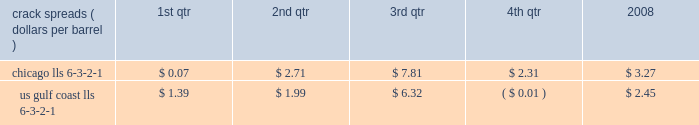Our refining and wholesale marketing gross margin is the difference between the prices of refined products sold and the costs of crude oil and other charge and blendstocks refined , including the costs to transport these inputs to our refineries , the costs of purchased products and manufacturing expenses , including depreciation .
The crack spread is a measure of the difference between market prices for refined products and crude oil , commonly used by the industry as an indicator of the impact of price on the refining margin .
Crack spreads can fluctuate significantly , particularly when prices of refined products do not move in the same relationship as the cost of crude oil .
As a performance benchmark and a comparison with other industry participants , we calculate midwest ( chicago ) and u.s .
Gulf coast crack spreads that we feel most closely track our operations and slate of products .
Posted light louisiana sweet ( 201clls 201d ) prices and a 6-3-2-1 ratio of products ( 6 barrels of crude oil producing 3 barrels of gasoline , 2 barrels of distillate and 1 barrel of residual fuel ) are used for the crack spread calculation .
The table lists calculated average crack spreads by quarter for the midwest ( chicago ) and gulf coast markets in 2008 .
Crack spreads ( dollars per barrel ) 1st qtr 2nd qtr 3rd qtr 4th qtr 2008 .
In addition to the market changes indicated by the crack spreads , our refining and wholesale marketing gross margin is impacted by factors such as the types of crude oil and other charge and blendstocks processed , the selling prices realized for refined products , the impact of commodity derivative instruments used to mitigate price risk and the cost of purchased products for resale .
We process significant amounts of sour crude oil which can enhance our profitability compared to certain of our competitors , as sour crude oil typically can be purchased at a discount to sweet crude oil .
Finally , our refining and wholesale marketing gross margin is impacted by changes in manufacturing costs , which are primarily driven by the level of maintenance activities at the refineries and the price of purchased natural gas used for plant fuel .
Our 2008 refining and wholesale marketing gross margin was the key driver of the 43 percent decrease in rm&t segment income when compared to 2007 .
Our average refining and wholesale marketing gross margin per gallon decreased 37 percent , to 11.66 cents in 2008 from 18.48 cents in 2007 , primarily due to the significant and rapid increases in crude oil prices early in 2008 and lagging wholesale price realizations .
Our retail marketing gross margin for gasoline and distillates , which is the difference between the ultimate price paid by consumers and the cost of refined products , including secondary transportation and consumer excise taxes , also impacts rm&t segment profitability .
While on average demand has been increasing for several years , there are numerous factors including local competition , seasonal demand fluctuations , the available wholesale supply , the level of economic activity in our marketing areas and weather conditions that impact gasoline and distillate demand throughout the year .
In 2008 , demand began to drop due to the combination of significant increases in retail petroleum prices and a broad slowdown in general activity .
The gross margin on merchandise sold at retail outlets has historically been more constant .
The profitability of our pipeline transportation operations is primarily dependent on the volumes shipped through our crude oil and refined products pipelines .
The volume of crude oil that we transport is directly affected by the supply of , and refiner demand for , crude oil in the markets served directly by our crude oil pipelines .
Key factors in this supply and demand balance are the production levels of crude oil by producers , the availability and cost of alternative modes of transportation , and refinery and transportation system maintenance levels .
The volume of refined products that we transport is directly affected by the production levels of , and user demand for , refined products in the markets served by our refined product pipelines .
In most of our markets , demand for gasoline peaks during the summer and declines during the fall and winter months , whereas distillate demand is more ratable throughout the year .
As with crude oil , other transportation alternatives and system maintenance levels influence refined product movements .
Integrated gas our integrated gas strategy is to link stranded natural gas resources with areas where a supply gap is emerging due to declining production and growing demand .
Our integrated gas operations include marketing and transportation of products manufactured from natural gas , such as lng and methanol , primarily in the u.s. , europe and west africa .
Our most significant lng investment is our 60 percent ownership in a production facility in equatorial guinea , which sells lng under a long-term contract at prices tied to henry hub natural gas prices .
In 2008 , its .
Was the average yearly crack spread for chicago lls 6-3-2-1 greater than the spread for us gulf coast lls 6-3-2-1 for 2008? 
Computations: (3.27 > 2.45)
Answer: yes. 